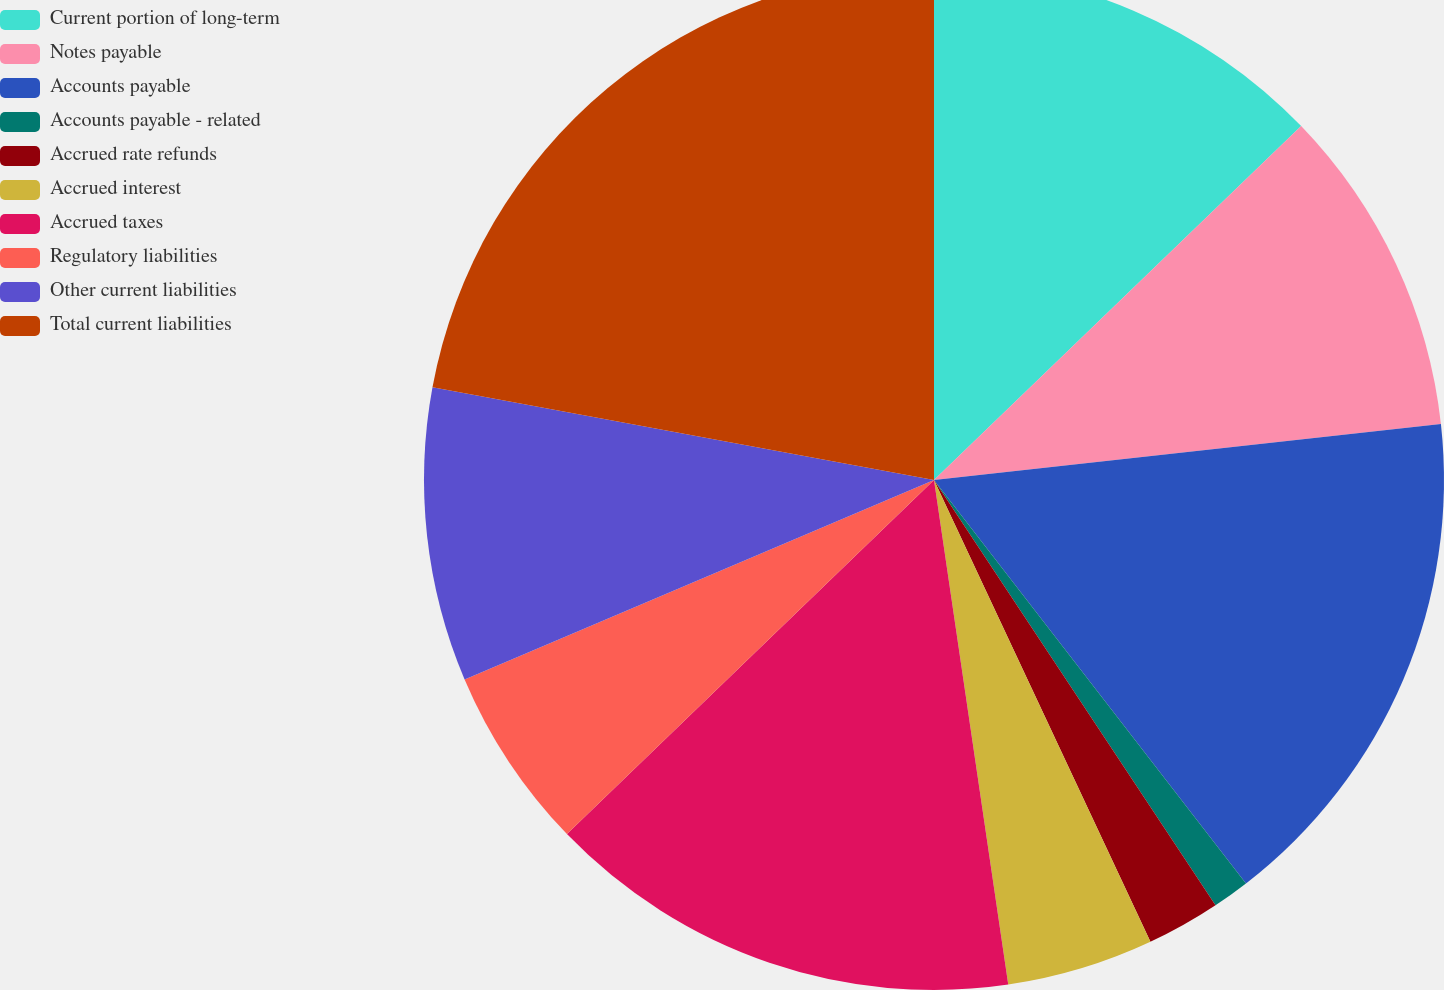Convert chart. <chart><loc_0><loc_0><loc_500><loc_500><pie_chart><fcel>Current portion of long-term<fcel>Notes payable<fcel>Accounts payable<fcel>Accounts payable - related<fcel>Accrued rate refunds<fcel>Accrued interest<fcel>Accrued taxes<fcel>Regulatory liabilities<fcel>Other current liabilities<fcel>Total current liabilities<nl><fcel>12.79%<fcel>10.46%<fcel>16.27%<fcel>1.17%<fcel>2.33%<fcel>4.65%<fcel>15.11%<fcel>5.82%<fcel>9.3%<fcel>22.09%<nl></chart> 